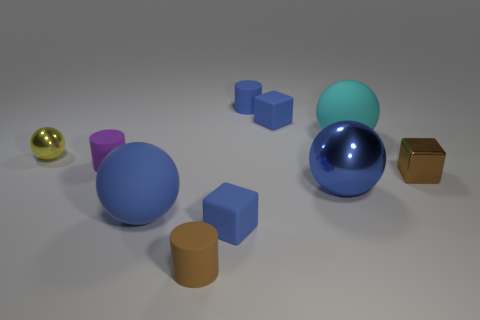Subtract all cyan spheres. How many spheres are left? 3 Subtract all small balls. How many balls are left? 3 Subtract all red balls. Subtract all brown blocks. How many balls are left? 4 Subtract all cubes. How many objects are left? 7 Add 5 brown cubes. How many brown cubes are left? 6 Add 5 gray things. How many gray things exist? 5 Subtract 0 cyan cylinders. How many objects are left? 10 Subtract all small cyan rubber blocks. Subtract all purple rubber cylinders. How many objects are left? 9 